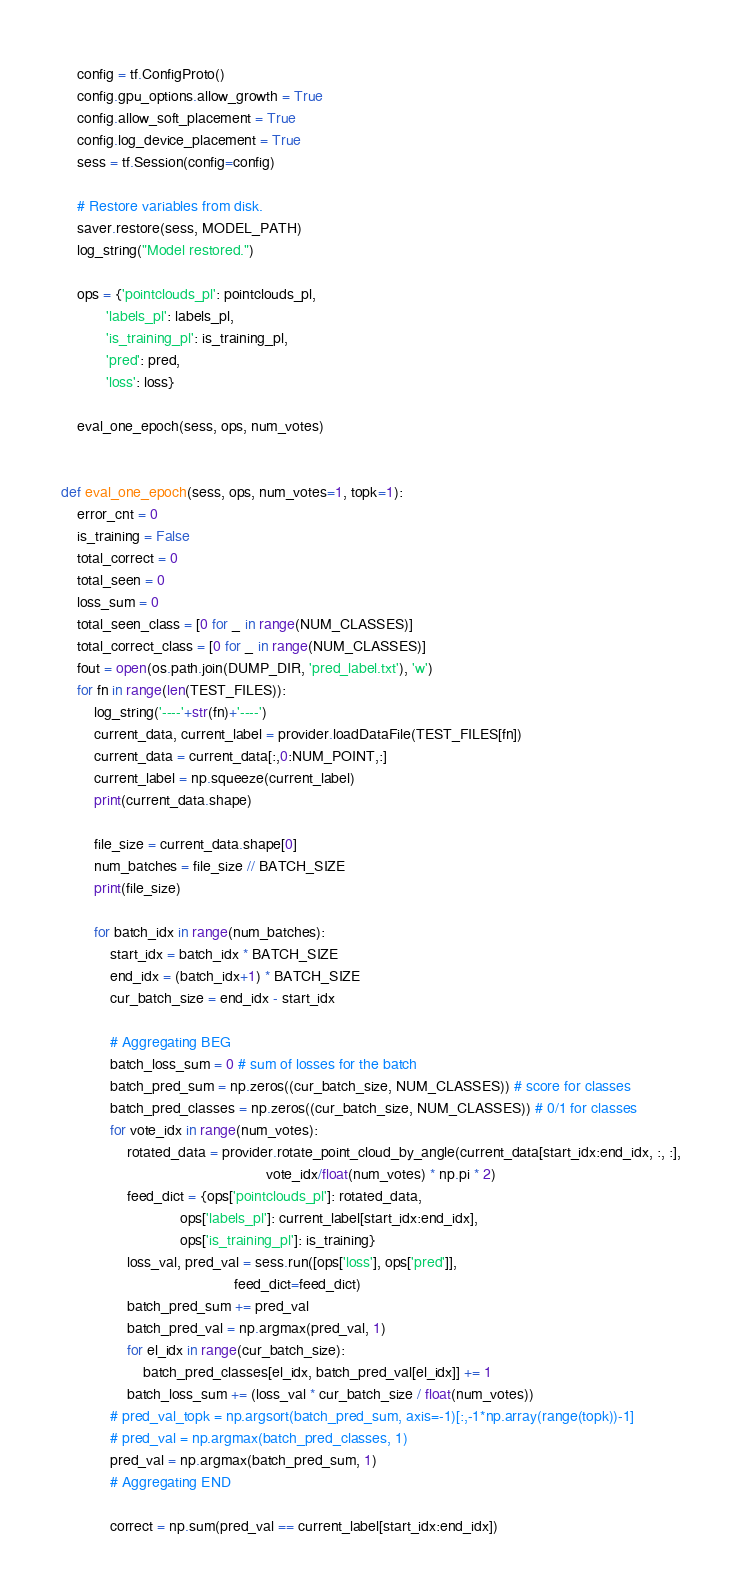<code> <loc_0><loc_0><loc_500><loc_500><_Python_>    config = tf.ConfigProto()
    config.gpu_options.allow_growth = True
    config.allow_soft_placement = True
    config.log_device_placement = True
    sess = tf.Session(config=config)

    # Restore variables from disk.
    saver.restore(sess, MODEL_PATH)
    log_string("Model restored.")

    ops = {'pointclouds_pl': pointclouds_pl,
           'labels_pl': labels_pl,
           'is_training_pl': is_training_pl,
           'pred': pred,
           'loss': loss}

    eval_one_epoch(sess, ops, num_votes)

   
def eval_one_epoch(sess, ops, num_votes=1, topk=1):
    error_cnt = 0
    is_training = False
    total_correct = 0
    total_seen = 0
    loss_sum = 0
    total_seen_class = [0 for _ in range(NUM_CLASSES)]
    total_correct_class = [0 for _ in range(NUM_CLASSES)]
    fout = open(os.path.join(DUMP_DIR, 'pred_label.txt'), 'w')
    for fn in range(len(TEST_FILES)):
        log_string('----'+str(fn)+'----')
        current_data, current_label = provider.loadDataFile(TEST_FILES[fn])
        current_data = current_data[:,0:NUM_POINT,:]
        current_label = np.squeeze(current_label)
        print(current_data.shape)
        
        file_size = current_data.shape[0]
        num_batches = file_size // BATCH_SIZE
        print(file_size)
        
        for batch_idx in range(num_batches):
            start_idx = batch_idx * BATCH_SIZE
            end_idx = (batch_idx+1) * BATCH_SIZE
            cur_batch_size = end_idx - start_idx
            
            # Aggregating BEG
            batch_loss_sum = 0 # sum of losses for the batch
            batch_pred_sum = np.zeros((cur_batch_size, NUM_CLASSES)) # score for classes
            batch_pred_classes = np.zeros((cur_batch_size, NUM_CLASSES)) # 0/1 for classes
            for vote_idx in range(num_votes):
                rotated_data = provider.rotate_point_cloud_by_angle(current_data[start_idx:end_idx, :, :],
                                                  vote_idx/float(num_votes) * np.pi * 2)
                feed_dict = {ops['pointclouds_pl']: rotated_data,
                             ops['labels_pl']: current_label[start_idx:end_idx],
                             ops['is_training_pl']: is_training}
                loss_val, pred_val = sess.run([ops['loss'], ops['pred']],
                                          feed_dict=feed_dict)
                batch_pred_sum += pred_val
                batch_pred_val = np.argmax(pred_val, 1)
                for el_idx in range(cur_batch_size):
                    batch_pred_classes[el_idx, batch_pred_val[el_idx]] += 1
                batch_loss_sum += (loss_val * cur_batch_size / float(num_votes))
            # pred_val_topk = np.argsort(batch_pred_sum, axis=-1)[:,-1*np.array(range(topk))-1]
            # pred_val = np.argmax(batch_pred_classes, 1)
            pred_val = np.argmax(batch_pred_sum, 1)
            # Aggregating END
            
            correct = np.sum(pred_val == current_label[start_idx:end_idx])</code> 